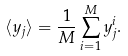<formula> <loc_0><loc_0><loc_500><loc_500>\langle y _ { j } \rangle = \frac { 1 } { M } \sum _ { i = 1 } ^ { M } y _ { j } ^ { i } .</formula> 